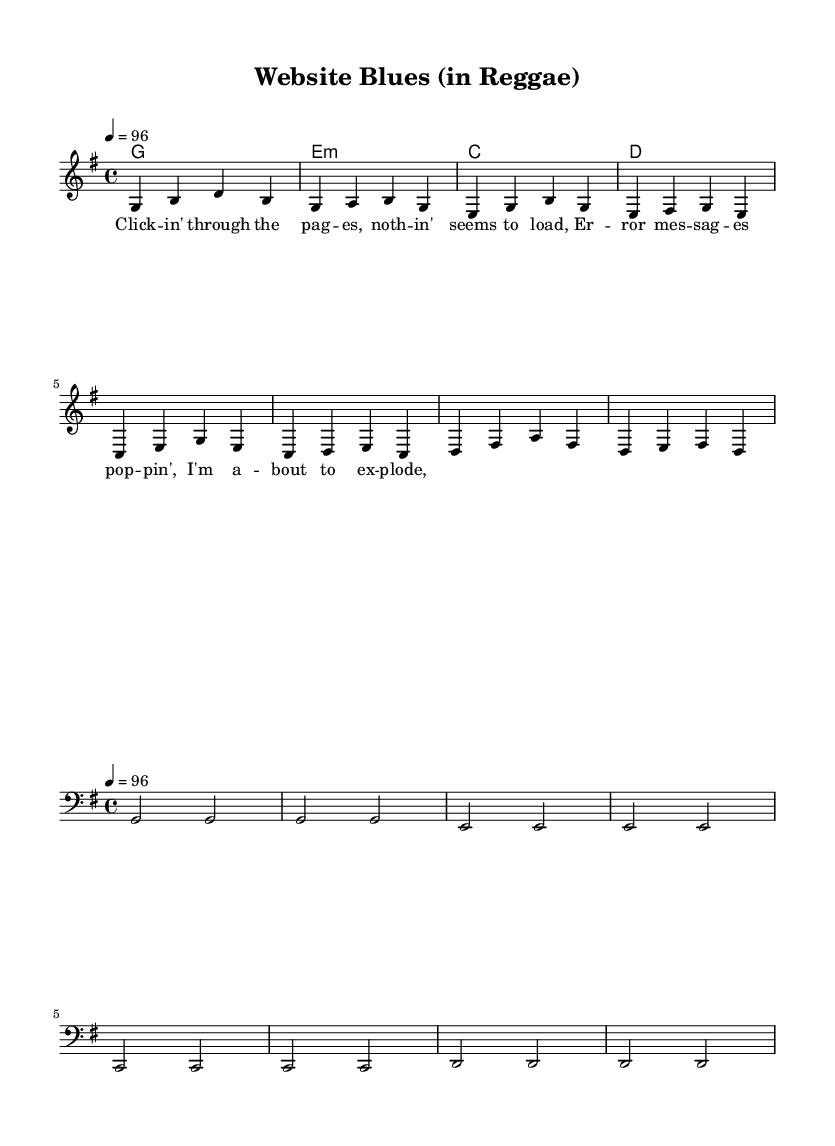What is the key signature of this music? The key signature shows one sharp on the staff, indicating it is in G major.
Answer: G major What is the time signature of this music? The time signature is located at the beginning of the staff and shows four beats per measure, denoted as 4/4.
Answer: 4/4 What is the tempo marking of the piece? The tempo marking is indicated at the start of the sheet music and states the piece should be played at a speed of 96 beats per minute.
Answer: 96 How many measures are in the melody section? By counting the number of measure bars in the melody notation, there are a total of eight measures.
Answer: Eight What is the first chord in the chord progression? The first chord shown in the chord names is indicated after the first bar, which is a G major chord.
Answer: G Does the piece use a bass line? Upon examining the bottom staff, it is clear that a bass line is present, which plays a foundational role in reggae music.
Answer: Yes What is the lyrical theme of the verse? The lyrics convey frustrations with online shopping, specifically the difficulty of navigating the website due to error messages.
Answer: Online shopping frustrations 